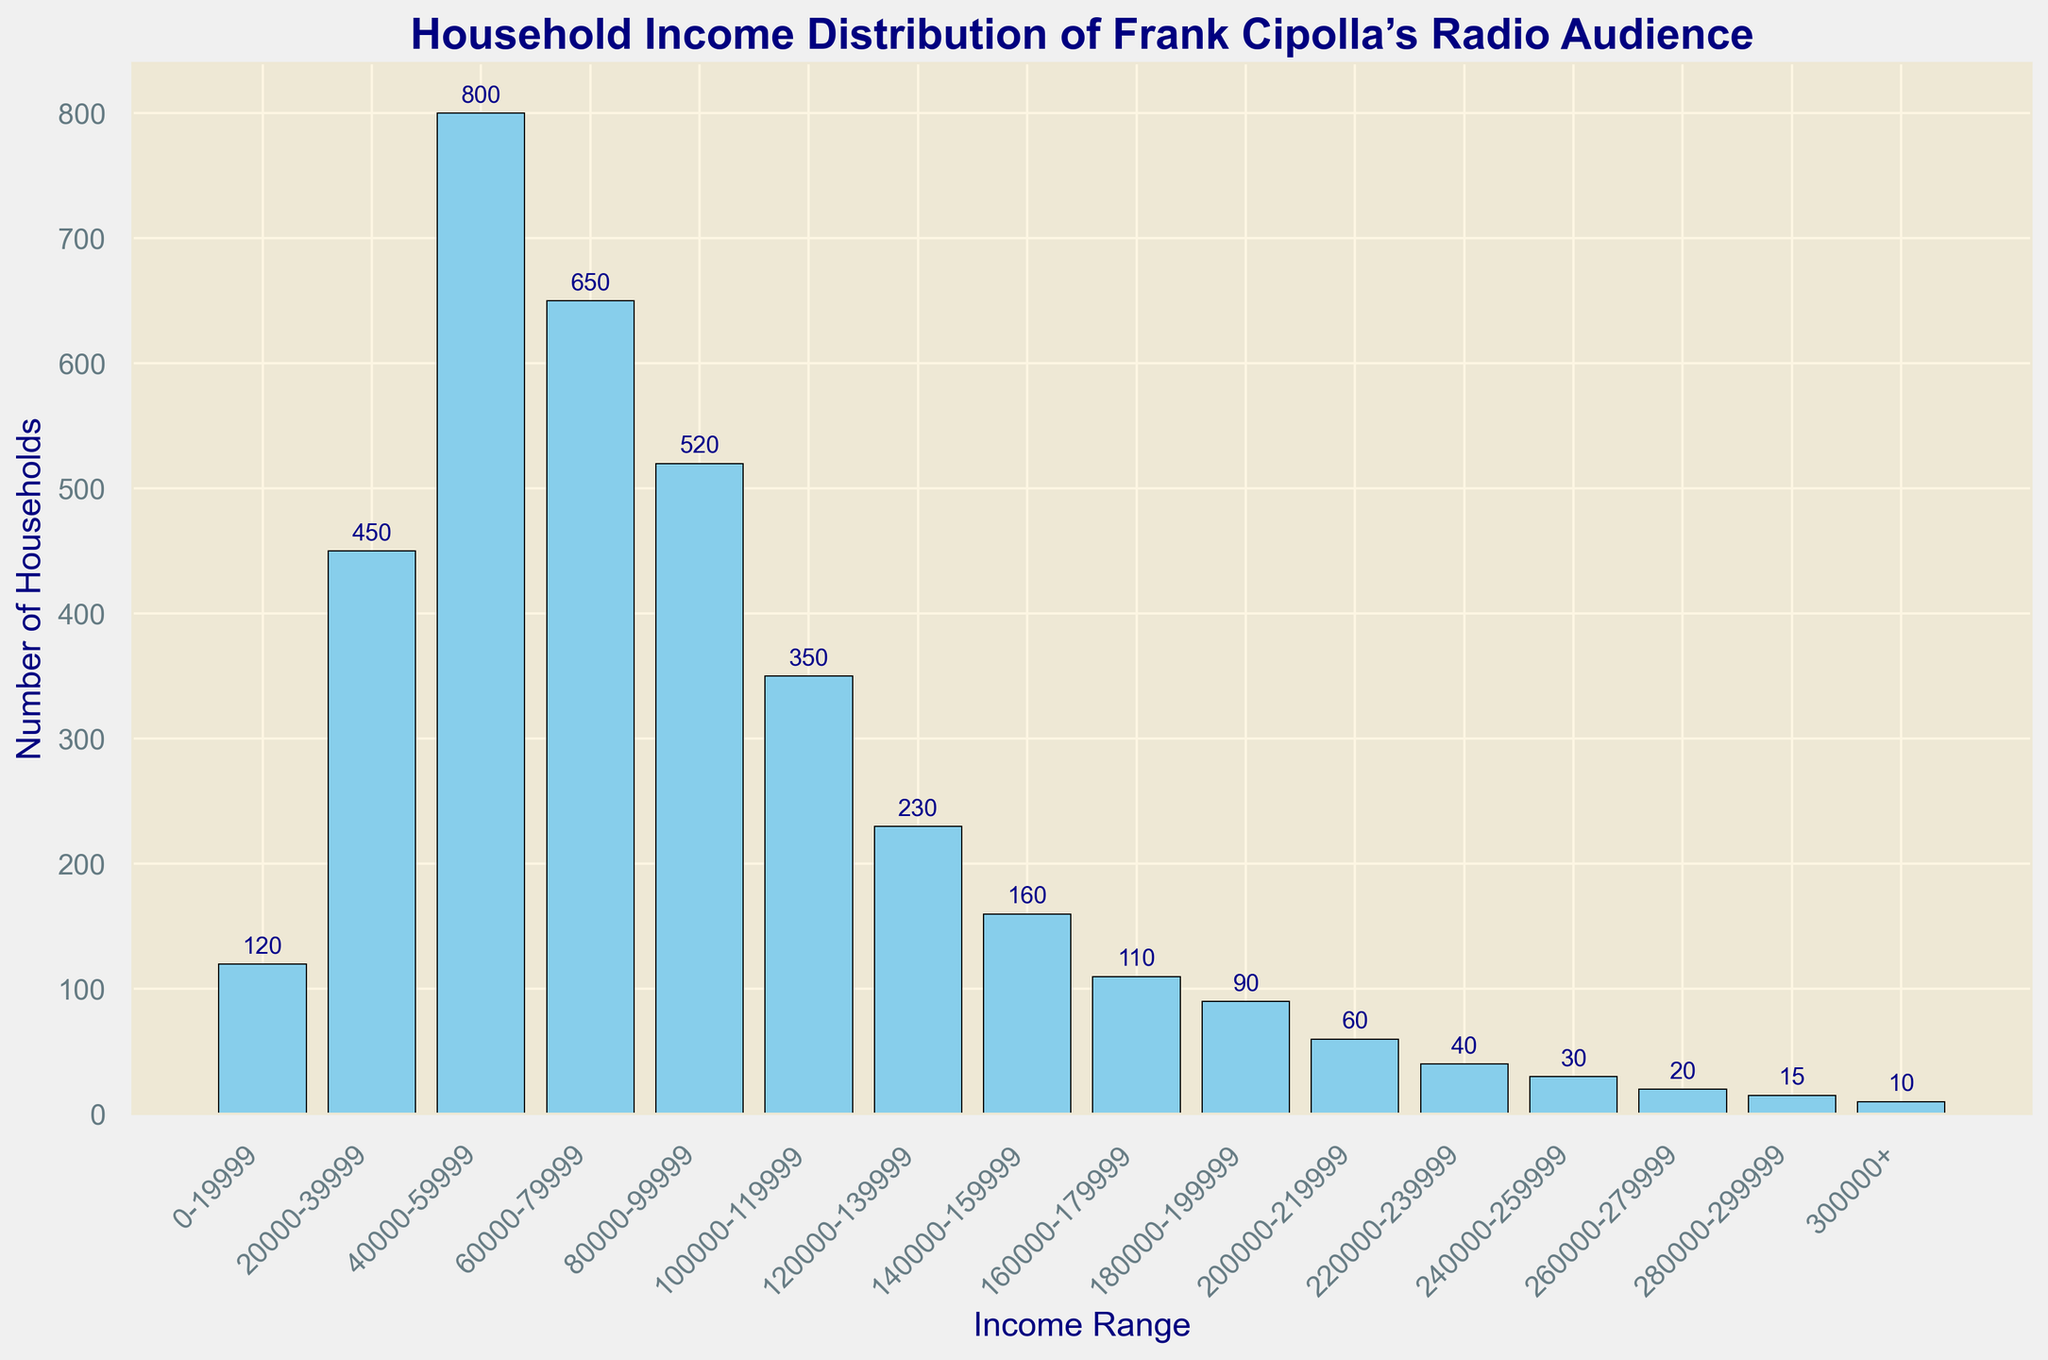What is the most common household income range among Frank Cipolla’s radio audience? The highest bar in the histogram represents the most common (mode) household income range. Here, the bar representing incomes of $40,000-$59,999 is the highest.
Answer: $40,000-$59,999 Which income range has the lowest number of households? The shortest bar in the histogram represents the income range with the fewest households. This is the bar for the $300,000+ income range.
Answer: $300,000+ What is the total number of households earning less than $100,000? To find the total number of households earning less than $100,000, sum the values of the bars for income ranges from $0-$99,999. These are 120, 450, 800, 650, and 520, which totals to 2540.
Answer: 2540 How many more households earn between $40,000-$59,999 than those earning between $200,000-$219,999? Subtract the number of households in the $200,000-$219,999 range from the number in the $40,000-$59,999 range: 800 - 60 = 740.
Answer: 740 Which income range has about half the number of households as the $40,000-$59,999 range? The $40,000-$59,999 range has 800 households. Approximately half of that is 400. The closest bar is for the $100,000-$119,999 range, with 350 households.
Answer: $100,000-$119,999 What is the combined number of households for income ranges between $100,000 and $159,999? Sum the number of households in the $100,000-$119,999, $120,000-$139,999, and $140,000-$159,999 ranges: 350 + 230 + 160 = 740.
Answer: 740 How does the number of households in the $160,000-$179,999 income range compare to the number in the $180,000-$199,999 income range? Compare the heights of the bars for these two ranges. The $160,000-$179,999 range has 110 households, and the $180,000-$199,999 range has 90 households. 110 is greater than 90.
Answer: $160,000-$179,999 is greater What is the approximate ratio of households earning $0-$19,999 to those earning $300,000+? Divide the number of households in the $0-$19,999 range by the number of households in the $300,000+ range: 120 / 10 = 12.
Answer: 12 Which income ranges fall below the median number of households? The median number is found by ordering the values and finding the middle number. In this case, the middle groups for 15 data points indicate the median is between 230 and 350. Therefore, income ranges with fewer than 230 households are: $160,000-$179,999, $180,000-$199,999, $200,000-$219,999, $220,000-$239,999, $240,000-$259,999, $260,000-$279,999, $280,000-$299,999, and $300,000+.
Answer: Eight income ranges starting from $160,000-$179,999 to $300,000+ How many total income ranges are represented in the histogram? Count the number of bars in the histogram. There are 16 bars that represent distinct income ranges from $0-$19,999 to $300,000+.
Answer: 16 